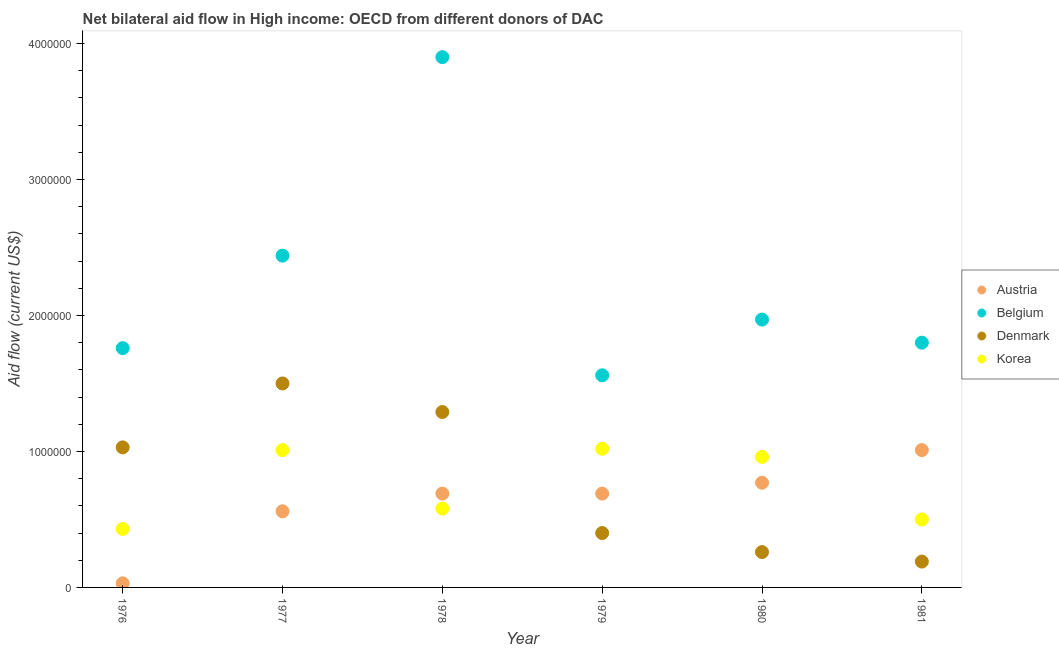Is the number of dotlines equal to the number of legend labels?
Offer a very short reply. Yes. What is the amount of aid given by denmark in 1981?
Ensure brevity in your answer.  1.90e+05. Across all years, what is the maximum amount of aid given by denmark?
Your answer should be very brief. 1.50e+06. Across all years, what is the minimum amount of aid given by belgium?
Your answer should be very brief. 1.56e+06. In which year was the amount of aid given by denmark maximum?
Your response must be concise. 1977. In which year was the amount of aid given by korea minimum?
Make the answer very short. 1976. What is the total amount of aid given by denmark in the graph?
Keep it short and to the point. 4.67e+06. What is the difference between the amount of aid given by korea in 1976 and that in 1979?
Your response must be concise. -5.90e+05. What is the difference between the amount of aid given by korea in 1978 and the amount of aid given by denmark in 1976?
Your answer should be compact. -4.50e+05. What is the average amount of aid given by denmark per year?
Your answer should be very brief. 7.78e+05. In the year 1980, what is the difference between the amount of aid given by belgium and amount of aid given by denmark?
Offer a very short reply. 1.71e+06. What is the ratio of the amount of aid given by korea in 1979 to that in 1981?
Give a very brief answer. 2.04. What is the difference between the highest and the second highest amount of aid given by korea?
Keep it short and to the point. 10000. What is the difference between the highest and the lowest amount of aid given by belgium?
Provide a succinct answer. 2.34e+06. Is the sum of the amount of aid given by korea in 1976 and 1980 greater than the maximum amount of aid given by austria across all years?
Offer a terse response. Yes. Is it the case that in every year, the sum of the amount of aid given by korea and amount of aid given by denmark is greater than the sum of amount of aid given by belgium and amount of aid given by austria?
Your answer should be compact. No. Is it the case that in every year, the sum of the amount of aid given by austria and amount of aid given by belgium is greater than the amount of aid given by denmark?
Your answer should be compact. Yes. Does the amount of aid given by belgium monotonically increase over the years?
Your answer should be very brief. No. How many dotlines are there?
Give a very brief answer. 4. How many years are there in the graph?
Make the answer very short. 6. What is the difference between two consecutive major ticks on the Y-axis?
Keep it short and to the point. 1.00e+06. Are the values on the major ticks of Y-axis written in scientific E-notation?
Keep it short and to the point. No. Where does the legend appear in the graph?
Provide a succinct answer. Center right. What is the title of the graph?
Offer a very short reply. Net bilateral aid flow in High income: OECD from different donors of DAC. What is the Aid flow (current US$) of Belgium in 1976?
Offer a very short reply. 1.76e+06. What is the Aid flow (current US$) in Denmark in 1976?
Keep it short and to the point. 1.03e+06. What is the Aid flow (current US$) in Korea in 1976?
Provide a short and direct response. 4.30e+05. What is the Aid flow (current US$) in Austria in 1977?
Your answer should be compact. 5.60e+05. What is the Aid flow (current US$) of Belgium in 1977?
Your answer should be compact. 2.44e+06. What is the Aid flow (current US$) in Denmark in 1977?
Offer a very short reply. 1.50e+06. What is the Aid flow (current US$) of Korea in 1977?
Give a very brief answer. 1.01e+06. What is the Aid flow (current US$) of Austria in 1978?
Provide a succinct answer. 6.90e+05. What is the Aid flow (current US$) of Belgium in 1978?
Offer a very short reply. 3.90e+06. What is the Aid flow (current US$) of Denmark in 1978?
Offer a very short reply. 1.29e+06. What is the Aid flow (current US$) in Korea in 1978?
Offer a very short reply. 5.80e+05. What is the Aid flow (current US$) in Austria in 1979?
Offer a very short reply. 6.90e+05. What is the Aid flow (current US$) in Belgium in 1979?
Your answer should be compact. 1.56e+06. What is the Aid flow (current US$) of Korea in 1979?
Provide a short and direct response. 1.02e+06. What is the Aid flow (current US$) of Austria in 1980?
Your answer should be very brief. 7.70e+05. What is the Aid flow (current US$) of Belgium in 1980?
Provide a succinct answer. 1.97e+06. What is the Aid flow (current US$) in Korea in 1980?
Offer a terse response. 9.60e+05. What is the Aid flow (current US$) of Austria in 1981?
Provide a succinct answer. 1.01e+06. What is the Aid flow (current US$) of Belgium in 1981?
Offer a terse response. 1.80e+06. What is the Aid flow (current US$) of Denmark in 1981?
Give a very brief answer. 1.90e+05. What is the Aid flow (current US$) of Korea in 1981?
Your answer should be compact. 5.00e+05. Across all years, what is the maximum Aid flow (current US$) of Austria?
Make the answer very short. 1.01e+06. Across all years, what is the maximum Aid flow (current US$) of Belgium?
Offer a terse response. 3.90e+06. Across all years, what is the maximum Aid flow (current US$) in Denmark?
Offer a very short reply. 1.50e+06. Across all years, what is the maximum Aid flow (current US$) of Korea?
Provide a short and direct response. 1.02e+06. Across all years, what is the minimum Aid flow (current US$) of Austria?
Make the answer very short. 3.00e+04. Across all years, what is the minimum Aid flow (current US$) of Belgium?
Your response must be concise. 1.56e+06. Across all years, what is the minimum Aid flow (current US$) of Korea?
Offer a very short reply. 4.30e+05. What is the total Aid flow (current US$) of Austria in the graph?
Offer a very short reply. 3.75e+06. What is the total Aid flow (current US$) of Belgium in the graph?
Ensure brevity in your answer.  1.34e+07. What is the total Aid flow (current US$) in Denmark in the graph?
Provide a succinct answer. 4.67e+06. What is the total Aid flow (current US$) in Korea in the graph?
Your answer should be compact. 4.50e+06. What is the difference between the Aid flow (current US$) in Austria in 1976 and that in 1977?
Keep it short and to the point. -5.30e+05. What is the difference between the Aid flow (current US$) of Belgium in 1976 and that in 1977?
Offer a very short reply. -6.80e+05. What is the difference between the Aid flow (current US$) in Denmark in 1976 and that in 1977?
Your response must be concise. -4.70e+05. What is the difference between the Aid flow (current US$) in Korea in 1976 and that in 1977?
Your answer should be compact. -5.80e+05. What is the difference between the Aid flow (current US$) in Austria in 1976 and that in 1978?
Your answer should be compact. -6.60e+05. What is the difference between the Aid flow (current US$) in Belgium in 1976 and that in 1978?
Offer a terse response. -2.14e+06. What is the difference between the Aid flow (current US$) of Korea in 1976 and that in 1978?
Your answer should be compact. -1.50e+05. What is the difference between the Aid flow (current US$) of Austria in 1976 and that in 1979?
Offer a very short reply. -6.60e+05. What is the difference between the Aid flow (current US$) in Belgium in 1976 and that in 1979?
Your answer should be compact. 2.00e+05. What is the difference between the Aid flow (current US$) in Denmark in 1976 and that in 1979?
Offer a terse response. 6.30e+05. What is the difference between the Aid flow (current US$) in Korea in 1976 and that in 1979?
Keep it short and to the point. -5.90e+05. What is the difference between the Aid flow (current US$) in Austria in 1976 and that in 1980?
Provide a short and direct response. -7.40e+05. What is the difference between the Aid flow (current US$) in Belgium in 1976 and that in 1980?
Provide a succinct answer. -2.10e+05. What is the difference between the Aid flow (current US$) in Denmark in 1976 and that in 1980?
Make the answer very short. 7.70e+05. What is the difference between the Aid flow (current US$) in Korea in 1976 and that in 1980?
Provide a short and direct response. -5.30e+05. What is the difference between the Aid flow (current US$) in Austria in 1976 and that in 1981?
Your answer should be compact. -9.80e+05. What is the difference between the Aid flow (current US$) of Denmark in 1976 and that in 1981?
Provide a short and direct response. 8.40e+05. What is the difference between the Aid flow (current US$) in Korea in 1976 and that in 1981?
Offer a terse response. -7.00e+04. What is the difference between the Aid flow (current US$) of Belgium in 1977 and that in 1978?
Ensure brevity in your answer.  -1.46e+06. What is the difference between the Aid flow (current US$) of Austria in 1977 and that in 1979?
Offer a terse response. -1.30e+05. What is the difference between the Aid flow (current US$) in Belgium in 1977 and that in 1979?
Make the answer very short. 8.80e+05. What is the difference between the Aid flow (current US$) of Denmark in 1977 and that in 1979?
Your answer should be compact. 1.10e+06. What is the difference between the Aid flow (current US$) in Korea in 1977 and that in 1979?
Provide a succinct answer. -10000. What is the difference between the Aid flow (current US$) of Austria in 1977 and that in 1980?
Offer a terse response. -2.10e+05. What is the difference between the Aid flow (current US$) of Denmark in 1977 and that in 1980?
Offer a terse response. 1.24e+06. What is the difference between the Aid flow (current US$) of Austria in 1977 and that in 1981?
Your response must be concise. -4.50e+05. What is the difference between the Aid flow (current US$) of Belgium in 1977 and that in 1981?
Ensure brevity in your answer.  6.40e+05. What is the difference between the Aid flow (current US$) in Denmark in 1977 and that in 1981?
Make the answer very short. 1.31e+06. What is the difference between the Aid flow (current US$) in Korea in 1977 and that in 1981?
Keep it short and to the point. 5.10e+05. What is the difference between the Aid flow (current US$) of Austria in 1978 and that in 1979?
Give a very brief answer. 0. What is the difference between the Aid flow (current US$) of Belgium in 1978 and that in 1979?
Keep it short and to the point. 2.34e+06. What is the difference between the Aid flow (current US$) of Denmark in 1978 and that in 1979?
Keep it short and to the point. 8.90e+05. What is the difference between the Aid flow (current US$) of Korea in 1978 and that in 1979?
Your response must be concise. -4.40e+05. What is the difference between the Aid flow (current US$) of Belgium in 1978 and that in 1980?
Your answer should be very brief. 1.93e+06. What is the difference between the Aid flow (current US$) of Denmark in 1978 and that in 1980?
Ensure brevity in your answer.  1.03e+06. What is the difference between the Aid flow (current US$) of Korea in 1978 and that in 1980?
Provide a short and direct response. -3.80e+05. What is the difference between the Aid flow (current US$) in Austria in 1978 and that in 1981?
Keep it short and to the point. -3.20e+05. What is the difference between the Aid flow (current US$) in Belgium in 1978 and that in 1981?
Provide a short and direct response. 2.10e+06. What is the difference between the Aid flow (current US$) in Denmark in 1978 and that in 1981?
Your response must be concise. 1.10e+06. What is the difference between the Aid flow (current US$) in Korea in 1978 and that in 1981?
Keep it short and to the point. 8.00e+04. What is the difference between the Aid flow (current US$) of Austria in 1979 and that in 1980?
Offer a very short reply. -8.00e+04. What is the difference between the Aid flow (current US$) of Belgium in 1979 and that in 1980?
Offer a very short reply. -4.10e+05. What is the difference between the Aid flow (current US$) of Denmark in 1979 and that in 1980?
Make the answer very short. 1.40e+05. What is the difference between the Aid flow (current US$) of Korea in 1979 and that in 1980?
Make the answer very short. 6.00e+04. What is the difference between the Aid flow (current US$) of Austria in 1979 and that in 1981?
Provide a short and direct response. -3.20e+05. What is the difference between the Aid flow (current US$) of Korea in 1979 and that in 1981?
Your answer should be very brief. 5.20e+05. What is the difference between the Aid flow (current US$) in Austria in 1980 and that in 1981?
Provide a succinct answer. -2.40e+05. What is the difference between the Aid flow (current US$) in Denmark in 1980 and that in 1981?
Offer a very short reply. 7.00e+04. What is the difference between the Aid flow (current US$) in Austria in 1976 and the Aid flow (current US$) in Belgium in 1977?
Your answer should be very brief. -2.41e+06. What is the difference between the Aid flow (current US$) in Austria in 1976 and the Aid flow (current US$) in Denmark in 1977?
Provide a succinct answer. -1.47e+06. What is the difference between the Aid flow (current US$) of Austria in 1976 and the Aid flow (current US$) of Korea in 1977?
Your answer should be very brief. -9.80e+05. What is the difference between the Aid flow (current US$) of Belgium in 1976 and the Aid flow (current US$) of Denmark in 1977?
Your answer should be compact. 2.60e+05. What is the difference between the Aid flow (current US$) in Belgium in 1976 and the Aid flow (current US$) in Korea in 1977?
Offer a terse response. 7.50e+05. What is the difference between the Aid flow (current US$) of Denmark in 1976 and the Aid flow (current US$) of Korea in 1977?
Your answer should be compact. 2.00e+04. What is the difference between the Aid flow (current US$) in Austria in 1976 and the Aid flow (current US$) in Belgium in 1978?
Your answer should be compact. -3.87e+06. What is the difference between the Aid flow (current US$) of Austria in 1976 and the Aid flow (current US$) of Denmark in 1978?
Give a very brief answer. -1.26e+06. What is the difference between the Aid flow (current US$) of Austria in 1976 and the Aid flow (current US$) of Korea in 1978?
Your answer should be very brief. -5.50e+05. What is the difference between the Aid flow (current US$) in Belgium in 1976 and the Aid flow (current US$) in Denmark in 1978?
Offer a very short reply. 4.70e+05. What is the difference between the Aid flow (current US$) of Belgium in 1976 and the Aid flow (current US$) of Korea in 1978?
Make the answer very short. 1.18e+06. What is the difference between the Aid flow (current US$) of Denmark in 1976 and the Aid flow (current US$) of Korea in 1978?
Provide a short and direct response. 4.50e+05. What is the difference between the Aid flow (current US$) of Austria in 1976 and the Aid flow (current US$) of Belgium in 1979?
Keep it short and to the point. -1.53e+06. What is the difference between the Aid flow (current US$) of Austria in 1976 and the Aid flow (current US$) of Denmark in 1979?
Give a very brief answer. -3.70e+05. What is the difference between the Aid flow (current US$) of Austria in 1976 and the Aid flow (current US$) of Korea in 1979?
Provide a short and direct response. -9.90e+05. What is the difference between the Aid flow (current US$) of Belgium in 1976 and the Aid flow (current US$) of Denmark in 1979?
Your response must be concise. 1.36e+06. What is the difference between the Aid flow (current US$) in Belgium in 1976 and the Aid flow (current US$) in Korea in 1979?
Your answer should be compact. 7.40e+05. What is the difference between the Aid flow (current US$) of Denmark in 1976 and the Aid flow (current US$) of Korea in 1979?
Your response must be concise. 10000. What is the difference between the Aid flow (current US$) of Austria in 1976 and the Aid flow (current US$) of Belgium in 1980?
Provide a succinct answer. -1.94e+06. What is the difference between the Aid flow (current US$) of Austria in 1976 and the Aid flow (current US$) of Denmark in 1980?
Your response must be concise. -2.30e+05. What is the difference between the Aid flow (current US$) of Austria in 1976 and the Aid flow (current US$) of Korea in 1980?
Your answer should be very brief. -9.30e+05. What is the difference between the Aid flow (current US$) of Belgium in 1976 and the Aid flow (current US$) of Denmark in 1980?
Provide a succinct answer. 1.50e+06. What is the difference between the Aid flow (current US$) in Austria in 1976 and the Aid flow (current US$) in Belgium in 1981?
Make the answer very short. -1.77e+06. What is the difference between the Aid flow (current US$) of Austria in 1976 and the Aid flow (current US$) of Korea in 1981?
Ensure brevity in your answer.  -4.70e+05. What is the difference between the Aid flow (current US$) of Belgium in 1976 and the Aid flow (current US$) of Denmark in 1981?
Keep it short and to the point. 1.57e+06. What is the difference between the Aid flow (current US$) of Belgium in 1976 and the Aid flow (current US$) of Korea in 1981?
Provide a short and direct response. 1.26e+06. What is the difference between the Aid flow (current US$) in Denmark in 1976 and the Aid flow (current US$) in Korea in 1981?
Your answer should be very brief. 5.30e+05. What is the difference between the Aid flow (current US$) of Austria in 1977 and the Aid flow (current US$) of Belgium in 1978?
Keep it short and to the point. -3.34e+06. What is the difference between the Aid flow (current US$) of Austria in 1977 and the Aid flow (current US$) of Denmark in 1978?
Provide a short and direct response. -7.30e+05. What is the difference between the Aid flow (current US$) of Austria in 1977 and the Aid flow (current US$) of Korea in 1978?
Make the answer very short. -2.00e+04. What is the difference between the Aid flow (current US$) in Belgium in 1977 and the Aid flow (current US$) in Denmark in 1978?
Provide a succinct answer. 1.15e+06. What is the difference between the Aid flow (current US$) of Belgium in 1977 and the Aid flow (current US$) of Korea in 1978?
Give a very brief answer. 1.86e+06. What is the difference between the Aid flow (current US$) in Denmark in 1977 and the Aid flow (current US$) in Korea in 1978?
Ensure brevity in your answer.  9.20e+05. What is the difference between the Aid flow (current US$) of Austria in 1977 and the Aid flow (current US$) of Denmark in 1979?
Your response must be concise. 1.60e+05. What is the difference between the Aid flow (current US$) in Austria in 1977 and the Aid flow (current US$) in Korea in 1979?
Your response must be concise. -4.60e+05. What is the difference between the Aid flow (current US$) in Belgium in 1977 and the Aid flow (current US$) in Denmark in 1979?
Provide a short and direct response. 2.04e+06. What is the difference between the Aid flow (current US$) in Belgium in 1977 and the Aid flow (current US$) in Korea in 1979?
Your answer should be compact. 1.42e+06. What is the difference between the Aid flow (current US$) in Austria in 1977 and the Aid flow (current US$) in Belgium in 1980?
Your answer should be very brief. -1.41e+06. What is the difference between the Aid flow (current US$) in Austria in 1977 and the Aid flow (current US$) in Korea in 1980?
Give a very brief answer. -4.00e+05. What is the difference between the Aid flow (current US$) in Belgium in 1977 and the Aid flow (current US$) in Denmark in 1980?
Ensure brevity in your answer.  2.18e+06. What is the difference between the Aid flow (current US$) in Belgium in 1977 and the Aid flow (current US$) in Korea in 1980?
Your answer should be compact. 1.48e+06. What is the difference between the Aid flow (current US$) in Denmark in 1977 and the Aid flow (current US$) in Korea in 1980?
Ensure brevity in your answer.  5.40e+05. What is the difference between the Aid flow (current US$) in Austria in 1977 and the Aid flow (current US$) in Belgium in 1981?
Provide a succinct answer. -1.24e+06. What is the difference between the Aid flow (current US$) of Austria in 1977 and the Aid flow (current US$) of Korea in 1981?
Provide a short and direct response. 6.00e+04. What is the difference between the Aid flow (current US$) in Belgium in 1977 and the Aid flow (current US$) in Denmark in 1981?
Make the answer very short. 2.25e+06. What is the difference between the Aid flow (current US$) of Belgium in 1977 and the Aid flow (current US$) of Korea in 1981?
Provide a succinct answer. 1.94e+06. What is the difference between the Aid flow (current US$) of Denmark in 1977 and the Aid flow (current US$) of Korea in 1981?
Your response must be concise. 1.00e+06. What is the difference between the Aid flow (current US$) in Austria in 1978 and the Aid flow (current US$) in Belgium in 1979?
Your answer should be very brief. -8.70e+05. What is the difference between the Aid flow (current US$) of Austria in 1978 and the Aid flow (current US$) of Denmark in 1979?
Provide a succinct answer. 2.90e+05. What is the difference between the Aid flow (current US$) of Austria in 1978 and the Aid flow (current US$) of Korea in 1979?
Your response must be concise. -3.30e+05. What is the difference between the Aid flow (current US$) of Belgium in 1978 and the Aid flow (current US$) of Denmark in 1979?
Provide a succinct answer. 3.50e+06. What is the difference between the Aid flow (current US$) in Belgium in 1978 and the Aid flow (current US$) in Korea in 1979?
Provide a short and direct response. 2.88e+06. What is the difference between the Aid flow (current US$) of Denmark in 1978 and the Aid flow (current US$) of Korea in 1979?
Your answer should be compact. 2.70e+05. What is the difference between the Aid flow (current US$) in Austria in 1978 and the Aid flow (current US$) in Belgium in 1980?
Your answer should be compact. -1.28e+06. What is the difference between the Aid flow (current US$) of Austria in 1978 and the Aid flow (current US$) of Korea in 1980?
Give a very brief answer. -2.70e+05. What is the difference between the Aid flow (current US$) of Belgium in 1978 and the Aid flow (current US$) of Denmark in 1980?
Make the answer very short. 3.64e+06. What is the difference between the Aid flow (current US$) in Belgium in 1978 and the Aid flow (current US$) in Korea in 1980?
Your response must be concise. 2.94e+06. What is the difference between the Aid flow (current US$) in Denmark in 1978 and the Aid flow (current US$) in Korea in 1980?
Your answer should be compact. 3.30e+05. What is the difference between the Aid flow (current US$) in Austria in 1978 and the Aid flow (current US$) in Belgium in 1981?
Make the answer very short. -1.11e+06. What is the difference between the Aid flow (current US$) in Austria in 1978 and the Aid flow (current US$) in Denmark in 1981?
Provide a succinct answer. 5.00e+05. What is the difference between the Aid flow (current US$) in Belgium in 1978 and the Aid flow (current US$) in Denmark in 1981?
Offer a very short reply. 3.71e+06. What is the difference between the Aid flow (current US$) of Belgium in 1978 and the Aid flow (current US$) of Korea in 1981?
Your answer should be compact. 3.40e+06. What is the difference between the Aid flow (current US$) of Denmark in 1978 and the Aid flow (current US$) of Korea in 1981?
Your answer should be very brief. 7.90e+05. What is the difference between the Aid flow (current US$) of Austria in 1979 and the Aid flow (current US$) of Belgium in 1980?
Your answer should be compact. -1.28e+06. What is the difference between the Aid flow (current US$) of Belgium in 1979 and the Aid flow (current US$) of Denmark in 1980?
Your response must be concise. 1.30e+06. What is the difference between the Aid flow (current US$) of Belgium in 1979 and the Aid flow (current US$) of Korea in 1980?
Your response must be concise. 6.00e+05. What is the difference between the Aid flow (current US$) of Denmark in 1979 and the Aid flow (current US$) of Korea in 1980?
Offer a very short reply. -5.60e+05. What is the difference between the Aid flow (current US$) of Austria in 1979 and the Aid flow (current US$) of Belgium in 1981?
Make the answer very short. -1.11e+06. What is the difference between the Aid flow (current US$) in Belgium in 1979 and the Aid flow (current US$) in Denmark in 1981?
Keep it short and to the point. 1.37e+06. What is the difference between the Aid flow (current US$) of Belgium in 1979 and the Aid flow (current US$) of Korea in 1981?
Your answer should be compact. 1.06e+06. What is the difference between the Aid flow (current US$) in Austria in 1980 and the Aid flow (current US$) in Belgium in 1981?
Offer a terse response. -1.03e+06. What is the difference between the Aid flow (current US$) of Austria in 1980 and the Aid flow (current US$) of Denmark in 1981?
Offer a very short reply. 5.80e+05. What is the difference between the Aid flow (current US$) in Austria in 1980 and the Aid flow (current US$) in Korea in 1981?
Your answer should be compact. 2.70e+05. What is the difference between the Aid flow (current US$) of Belgium in 1980 and the Aid flow (current US$) of Denmark in 1981?
Provide a short and direct response. 1.78e+06. What is the difference between the Aid flow (current US$) in Belgium in 1980 and the Aid flow (current US$) in Korea in 1981?
Offer a terse response. 1.47e+06. What is the difference between the Aid flow (current US$) of Denmark in 1980 and the Aid flow (current US$) of Korea in 1981?
Provide a short and direct response. -2.40e+05. What is the average Aid flow (current US$) in Austria per year?
Provide a succinct answer. 6.25e+05. What is the average Aid flow (current US$) of Belgium per year?
Your answer should be very brief. 2.24e+06. What is the average Aid flow (current US$) in Denmark per year?
Keep it short and to the point. 7.78e+05. What is the average Aid flow (current US$) of Korea per year?
Your response must be concise. 7.50e+05. In the year 1976, what is the difference between the Aid flow (current US$) of Austria and Aid flow (current US$) of Belgium?
Give a very brief answer. -1.73e+06. In the year 1976, what is the difference between the Aid flow (current US$) of Austria and Aid flow (current US$) of Korea?
Provide a short and direct response. -4.00e+05. In the year 1976, what is the difference between the Aid flow (current US$) in Belgium and Aid flow (current US$) in Denmark?
Offer a very short reply. 7.30e+05. In the year 1976, what is the difference between the Aid flow (current US$) of Belgium and Aid flow (current US$) of Korea?
Offer a very short reply. 1.33e+06. In the year 1976, what is the difference between the Aid flow (current US$) of Denmark and Aid flow (current US$) of Korea?
Keep it short and to the point. 6.00e+05. In the year 1977, what is the difference between the Aid flow (current US$) in Austria and Aid flow (current US$) in Belgium?
Provide a succinct answer. -1.88e+06. In the year 1977, what is the difference between the Aid flow (current US$) in Austria and Aid flow (current US$) in Denmark?
Keep it short and to the point. -9.40e+05. In the year 1977, what is the difference between the Aid flow (current US$) in Austria and Aid flow (current US$) in Korea?
Keep it short and to the point. -4.50e+05. In the year 1977, what is the difference between the Aid flow (current US$) in Belgium and Aid flow (current US$) in Denmark?
Make the answer very short. 9.40e+05. In the year 1977, what is the difference between the Aid flow (current US$) of Belgium and Aid flow (current US$) of Korea?
Your response must be concise. 1.43e+06. In the year 1978, what is the difference between the Aid flow (current US$) in Austria and Aid flow (current US$) in Belgium?
Provide a succinct answer. -3.21e+06. In the year 1978, what is the difference between the Aid flow (current US$) in Austria and Aid flow (current US$) in Denmark?
Ensure brevity in your answer.  -6.00e+05. In the year 1978, what is the difference between the Aid flow (current US$) of Austria and Aid flow (current US$) of Korea?
Keep it short and to the point. 1.10e+05. In the year 1978, what is the difference between the Aid flow (current US$) of Belgium and Aid flow (current US$) of Denmark?
Make the answer very short. 2.61e+06. In the year 1978, what is the difference between the Aid flow (current US$) in Belgium and Aid flow (current US$) in Korea?
Your answer should be compact. 3.32e+06. In the year 1978, what is the difference between the Aid flow (current US$) of Denmark and Aid flow (current US$) of Korea?
Your answer should be very brief. 7.10e+05. In the year 1979, what is the difference between the Aid flow (current US$) of Austria and Aid flow (current US$) of Belgium?
Offer a very short reply. -8.70e+05. In the year 1979, what is the difference between the Aid flow (current US$) of Austria and Aid flow (current US$) of Denmark?
Your answer should be compact. 2.90e+05. In the year 1979, what is the difference between the Aid flow (current US$) of Austria and Aid flow (current US$) of Korea?
Keep it short and to the point. -3.30e+05. In the year 1979, what is the difference between the Aid flow (current US$) in Belgium and Aid flow (current US$) in Denmark?
Keep it short and to the point. 1.16e+06. In the year 1979, what is the difference between the Aid flow (current US$) in Belgium and Aid flow (current US$) in Korea?
Provide a succinct answer. 5.40e+05. In the year 1979, what is the difference between the Aid flow (current US$) of Denmark and Aid flow (current US$) of Korea?
Give a very brief answer. -6.20e+05. In the year 1980, what is the difference between the Aid flow (current US$) of Austria and Aid flow (current US$) of Belgium?
Your answer should be compact. -1.20e+06. In the year 1980, what is the difference between the Aid flow (current US$) in Austria and Aid flow (current US$) in Denmark?
Offer a very short reply. 5.10e+05. In the year 1980, what is the difference between the Aid flow (current US$) of Austria and Aid flow (current US$) of Korea?
Make the answer very short. -1.90e+05. In the year 1980, what is the difference between the Aid flow (current US$) in Belgium and Aid flow (current US$) in Denmark?
Offer a terse response. 1.71e+06. In the year 1980, what is the difference between the Aid flow (current US$) in Belgium and Aid flow (current US$) in Korea?
Give a very brief answer. 1.01e+06. In the year 1980, what is the difference between the Aid flow (current US$) of Denmark and Aid flow (current US$) of Korea?
Your response must be concise. -7.00e+05. In the year 1981, what is the difference between the Aid flow (current US$) in Austria and Aid flow (current US$) in Belgium?
Offer a terse response. -7.90e+05. In the year 1981, what is the difference between the Aid flow (current US$) in Austria and Aid flow (current US$) in Denmark?
Your answer should be very brief. 8.20e+05. In the year 1981, what is the difference between the Aid flow (current US$) of Austria and Aid flow (current US$) of Korea?
Make the answer very short. 5.10e+05. In the year 1981, what is the difference between the Aid flow (current US$) in Belgium and Aid flow (current US$) in Denmark?
Keep it short and to the point. 1.61e+06. In the year 1981, what is the difference between the Aid flow (current US$) in Belgium and Aid flow (current US$) in Korea?
Provide a succinct answer. 1.30e+06. In the year 1981, what is the difference between the Aid flow (current US$) in Denmark and Aid flow (current US$) in Korea?
Offer a very short reply. -3.10e+05. What is the ratio of the Aid flow (current US$) in Austria in 1976 to that in 1977?
Ensure brevity in your answer.  0.05. What is the ratio of the Aid flow (current US$) in Belgium in 1976 to that in 1977?
Keep it short and to the point. 0.72. What is the ratio of the Aid flow (current US$) in Denmark in 1976 to that in 1977?
Make the answer very short. 0.69. What is the ratio of the Aid flow (current US$) in Korea in 1976 to that in 1977?
Your response must be concise. 0.43. What is the ratio of the Aid flow (current US$) of Austria in 1976 to that in 1978?
Your answer should be very brief. 0.04. What is the ratio of the Aid flow (current US$) in Belgium in 1976 to that in 1978?
Your answer should be very brief. 0.45. What is the ratio of the Aid flow (current US$) of Denmark in 1976 to that in 1978?
Ensure brevity in your answer.  0.8. What is the ratio of the Aid flow (current US$) of Korea in 1976 to that in 1978?
Provide a succinct answer. 0.74. What is the ratio of the Aid flow (current US$) in Austria in 1976 to that in 1979?
Offer a terse response. 0.04. What is the ratio of the Aid flow (current US$) in Belgium in 1976 to that in 1979?
Give a very brief answer. 1.13. What is the ratio of the Aid flow (current US$) in Denmark in 1976 to that in 1979?
Give a very brief answer. 2.58. What is the ratio of the Aid flow (current US$) of Korea in 1976 to that in 1979?
Offer a very short reply. 0.42. What is the ratio of the Aid flow (current US$) in Austria in 1976 to that in 1980?
Ensure brevity in your answer.  0.04. What is the ratio of the Aid flow (current US$) of Belgium in 1976 to that in 1980?
Your answer should be compact. 0.89. What is the ratio of the Aid flow (current US$) of Denmark in 1976 to that in 1980?
Your response must be concise. 3.96. What is the ratio of the Aid flow (current US$) of Korea in 1976 to that in 1980?
Provide a succinct answer. 0.45. What is the ratio of the Aid flow (current US$) in Austria in 1976 to that in 1981?
Your answer should be compact. 0.03. What is the ratio of the Aid flow (current US$) in Belgium in 1976 to that in 1981?
Provide a short and direct response. 0.98. What is the ratio of the Aid flow (current US$) in Denmark in 1976 to that in 1981?
Your answer should be very brief. 5.42. What is the ratio of the Aid flow (current US$) of Korea in 1976 to that in 1981?
Provide a short and direct response. 0.86. What is the ratio of the Aid flow (current US$) in Austria in 1977 to that in 1978?
Keep it short and to the point. 0.81. What is the ratio of the Aid flow (current US$) in Belgium in 1977 to that in 1978?
Your answer should be compact. 0.63. What is the ratio of the Aid flow (current US$) of Denmark in 1977 to that in 1978?
Make the answer very short. 1.16. What is the ratio of the Aid flow (current US$) in Korea in 1977 to that in 1978?
Offer a very short reply. 1.74. What is the ratio of the Aid flow (current US$) of Austria in 1977 to that in 1979?
Ensure brevity in your answer.  0.81. What is the ratio of the Aid flow (current US$) in Belgium in 1977 to that in 1979?
Make the answer very short. 1.56. What is the ratio of the Aid flow (current US$) of Denmark in 1977 to that in 1979?
Make the answer very short. 3.75. What is the ratio of the Aid flow (current US$) in Korea in 1977 to that in 1979?
Provide a succinct answer. 0.99. What is the ratio of the Aid flow (current US$) of Austria in 1977 to that in 1980?
Give a very brief answer. 0.73. What is the ratio of the Aid flow (current US$) of Belgium in 1977 to that in 1980?
Keep it short and to the point. 1.24. What is the ratio of the Aid flow (current US$) of Denmark in 1977 to that in 1980?
Give a very brief answer. 5.77. What is the ratio of the Aid flow (current US$) of Korea in 1977 to that in 1980?
Your answer should be compact. 1.05. What is the ratio of the Aid flow (current US$) in Austria in 1977 to that in 1981?
Give a very brief answer. 0.55. What is the ratio of the Aid flow (current US$) of Belgium in 1977 to that in 1981?
Provide a short and direct response. 1.36. What is the ratio of the Aid flow (current US$) in Denmark in 1977 to that in 1981?
Your answer should be compact. 7.89. What is the ratio of the Aid flow (current US$) in Korea in 1977 to that in 1981?
Your answer should be compact. 2.02. What is the ratio of the Aid flow (current US$) of Austria in 1978 to that in 1979?
Provide a short and direct response. 1. What is the ratio of the Aid flow (current US$) in Belgium in 1978 to that in 1979?
Give a very brief answer. 2.5. What is the ratio of the Aid flow (current US$) in Denmark in 1978 to that in 1979?
Your answer should be compact. 3.23. What is the ratio of the Aid flow (current US$) of Korea in 1978 to that in 1979?
Your response must be concise. 0.57. What is the ratio of the Aid flow (current US$) in Austria in 1978 to that in 1980?
Your answer should be very brief. 0.9. What is the ratio of the Aid flow (current US$) in Belgium in 1978 to that in 1980?
Provide a succinct answer. 1.98. What is the ratio of the Aid flow (current US$) of Denmark in 1978 to that in 1980?
Offer a very short reply. 4.96. What is the ratio of the Aid flow (current US$) in Korea in 1978 to that in 1980?
Your response must be concise. 0.6. What is the ratio of the Aid flow (current US$) of Austria in 1978 to that in 1981?
Your answer should be compact. 0.68. What is the ratio of the Aid flow (current US$) in Belgium in 1978 to that in 1981?
Offer a terse response. 2.17. What is the ratio of the Aid flow (current US$) in Denmark in 1978 to that in 1981?
Your answer should be compact. 6.79. What is the ratio of the Aid flow (current US$) in Korea in 1978 to that in 1981?
Give a very brief answer. 1.16. What is the ratio of the Aid flow (current US$) in Austria in 1979 to that in 1980?
Your response must be concise. 0.9. What is the ratio of the Aid flow (current US$) of Belgium in 1979 to that in 1980?
Make the answer very short. 0.79. What is the ratio of the Aid flow (current US$) of Denmark in 1979 to that in 1980?
Ensure brevity in your answer.  1.54. What is the ratio of the Aid flow (current US$) in Austria in 1979 to that in 1981?
Ensure brevity in your answer.  0.68. What is the ratio of the Aid flow (current US$) in Belgium in 1979 to that in 1981?
Provide a succinct answer. 0.87. What is the ratio of the Aid flow (current US$) in Denmark in 1979 to that in 1981?
Give a very brief answer. 2.11. What is the ratio of the Aid flow (current US$) of Korea in 1979 to that in 1981?
Your response must be concise. 2.04. What is the ratio of the Aid flow (current US$) of Austria in 1980 to that in 1981?
Ensure brevity in your answer.  0.76. What is the ratio of the Aid flow (current US$) of Belgium in 1980 to that in 1981?
Give a very brief answer. 1.09. What is the ratio of the Aid flow (current US$) in Denmark in 1980 to that in 1981?
Ensure brevity in your answer.  1.37. What is the ratio of the Aid flow (current US$) in Korea in 1980 to that in 1981?
Provide a short and direct response. 1.92. What is the difference between the highest and the second highest Aid flow (current US$) of Belgium?
Your answer should be very brief. 1.46e+06. What is the difference between the highest and the second highest Aid flow (current US$) of Korea?
Your response must be concise. 10000. What is the difference between the highest and the lowest Aid flow (current US$) in Austria?
Your answer should be very brief. 9.80e+05. What is the difference between the highest and the lowest Aid flow (current US$) of Belgium?
Keep it short and to the point. 2.34e+06. What is the difference between the highest and the lowest Aid flow (current US$) in Denmark?
Provide a short and direct response. 1.31e+06. What is the difference between the highest and the lowest Aid flow (current US$) in Korea?
Your response must be concise. 5.90e+05. 